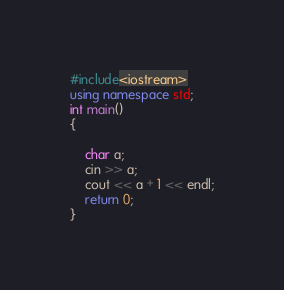<code> <loc_0><loc_0><loc_500><loc_500><_C++_>#include<iostream>
using namespace std;
int main()
{
    
    char a;
    cin >> a;
    cout << a + 1 << endl;
    return 0;
}</code> 